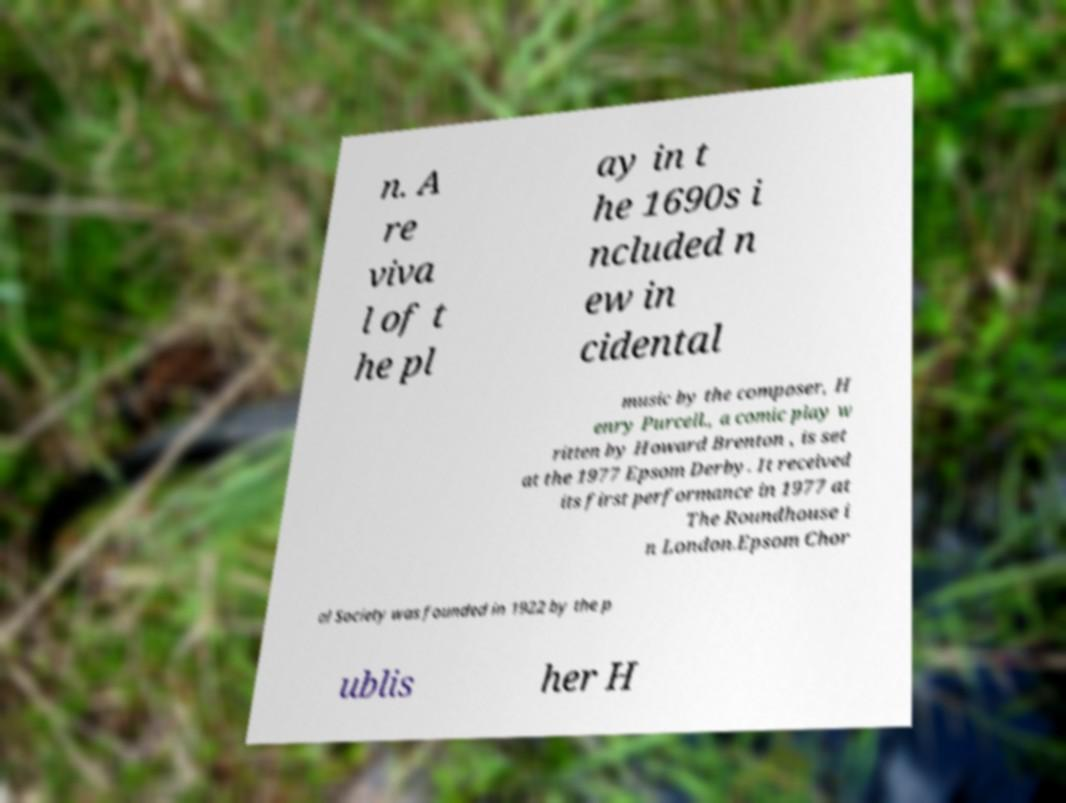Could you assist in decoding the text presented in this image and type it out clearly? n. A re viva l of t he pl ay in t he 1690s i ncluded n ew in cidental music by the composer, H enry Purcell., a comic play w ritten by Howard Brenton , is set at the 1977 Epsom Derby. It received its first performance in 1977 at The Roundhouse i n London.Epsom Chor al Society was founded in 1922 by the p ublis her H 